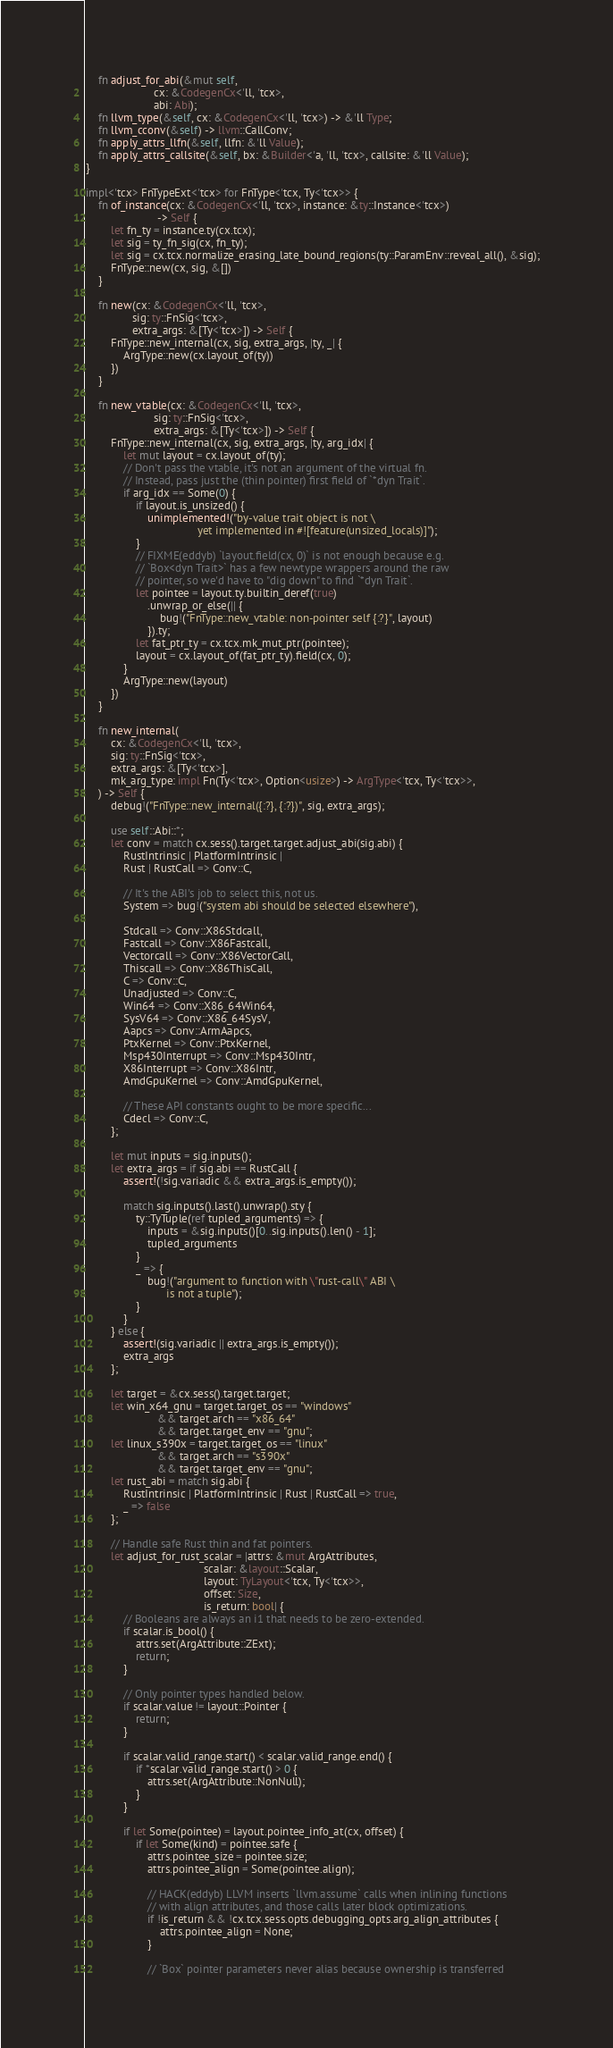<code> <loc_0><loc_0><loc_500><loc_500><_Rust_>    fn adjust_for_abi(&mut self,
                      cx: &CodegenCx<'ll, 'tcx>,
                      abi: Abi);
    fn llvm_type(&self, cx: &CodegenCx<'ll, 'tcx>) -> &'ll Type;
    fn llvm_cconv(&self) -> llvm::CallConv;
    fn apply_attrs_llfn(&self, llfn: &'ll Value);
    fn apply_attrs_callsite(&self, bx: &Builder<'a, 'll, 'tcx>, callsite: &'ll Value);
}

impl<'tcx> FnTypeExt<'tcx> for FnType<'tcx, Ty<'tcx>> {
    fn of_instance(cx: &CodegenCx<'ll, 'tcx>, instance: &ty::Instance<'tcx>)
                       -> Self {
        let fn_ty = instance.ty(cx.tcx);
        let sig = ty_fn_sig(cx, fn_ty);
        let sig = cx.tcx.normalize_erasing_late_bound_regions(ty::ParamEnv::reveal_all(), &sig);
        FnType::new(cx, sig, &[])
    }

    fn new(cx: &CodegenCx<'ll, 'tcx>,
               sig: ty::FnSig<'tcx>,
               extra_args: &[Ty<'tcx>]) -> Self {
        FnType::new_internal(cx, sig, extra_args, |ty, _| {
            ArgType::new(cx.layout_of(ty))
        })
    }

    fn new_vtable(cx: &CodegenCx<'ll, 'tcx>,
                      sig: ty::FnSig<'tcx>,
                      extra_args: &[Ty<'tcx>]) -> Self {
        FnType::new_internal(cx, sig, extra_args, |ty, arg_idx| {
            let mut layout = cx.layout_of(ty);
            // Don't pass the vtable, it's not an argument of the virtual fn.
            // Instead, pass just the (thin pointer) first field of `*dyn Trait`.
            if arg_idx == Some(0) {
                if layout.is_unsized() {
                    unimplemented!("by-value trait object is not \
                                    yet implemented in #![feature(unsized_locals)]");
                }
                // FIXME(eddyb) `layout.field(cx, 0)` is not enough because e.g.
                // `Box<dyn Trait>` has a few newtype wrappers around the raw
                // pointer, so we'd have to "dig down" to find `*dyn Trait`.
                let pointee = layout.ty.builtin_deref(true)
                    .unwrap_or_else(|| {
                        bug!("FnType::new_vtable: non-pointer self {:?}", layout)
                    }).ty;
                let fat_ptr_ty = cx.tcx.mk_mut_ptr(pointee);
                layout = cx.layout_of(fat_ptr_ty).field(cx, 0);
            }
            ArgType::new(layout)
        })
    }

    fn new_internal(
        cx: &CodegenCx<'ll, 'tcx>,
        sig: ty::FnSig<'tcx>,
        extra_args: &[Ty<'tcx>],
        mk_arg_type: impl Fn(Ty<'tcx>, Option<usize>) -> ArgType<'tcx, Ty<'tcx>>,
    ) -> Self {
        debug!("FnType::new_internal({:?}, {:?})", sig, extra_args);

        use self::Abi::*;
        let conv = match cx.sess().target.target.adjust_abi(sig.abi) {
            RustIntrinsic | PlatformIntrinsic |
            Rust | RustCall => Conv::C,

            // It's the ABI's job to select this, not us.
            System => bug!("system abi should be selected elsewhere"),

            Stdcall => Conv::X86Stdcall,
            Fastcall => Conv::X86Fastcall,
            Vectorcall => Conv::X86VectorCall,
            Thiscall => Conv::X86ThisCall,
            C => Conv::C,
            Unadjusted => Conv::C,
            Win64 => Conv::X86_64Win64,
            SysV64 => Conv::X86_64SysV,
            Aapcs => Conv::ArmAapcs,
            PtxKernel => Conv::PtxKernel,
            Msp430Interrupt => Conv::Msp430Intr,
            X86Interrupt => Conv::X86Intr,
            AmdGpuKernel => Conv::AmdGpuKernel,

            // These API constants ought to be more specific...
            Cdecl => Conv::C,
        };

        let mut inputs = sig.inputs();
        let extra_args = if sig.abi == RustCall {
            assert!(!sig.variadic && extra_args.is_empty());

            match sig.inputs().last().unwrap().sty {
                ty::TyTuple(ref tupled_arguments) => {
                    inputs = &sig.inputs()[0..sig.inputs().len() - 1];
                    tupled_arguments
                }
                _ => {
                    bug!("argument to function with \"rust-call\" ABI \
                          is not a tuple");
                }
            }
        } else {
            assert!(sig.variadic || extra_args.is_empty());
            extra_args
        };

        let target = &cx.sess().target.target;
        let win_x64_gnu = target.target_os == "windows"
                       && target.arch == "x86_64"
                       && target.target_env == "gnu";
        let linux_s390x = target.target_os == "linux"
                       && target.arch == "s390x"
                       && target.target_env == "gnu";
        let rust_abi = match sig.abi {
            RustIntrinsic | PlatformIntrinsic | Rust | RustCall => true,
            _ => false
        };

        // Handle safe Rust thin and fat pointers.
        let adjust_for_rust_scalar = |attrs: &mut ArgAttributes,
                                      scalar: &layout::Scalar,
                                      layout: TyLayout<'tcx, Ty<'tcx>>,
                                      offset: Size,
                                      is_return: bool| {
            // Booleans are always an i1 that needs to be zero-extended.
            if scalar.is_bool() {
                attrs.set(ArgAttribute::ZExt);
                return;
            }

            // Only pointer types handled below.
            if scalar.value != layout::Pointer {
                return;
            }

            if scalar.valid_range.start() < scalar.valid_range.end() {
                if *scalar.valid_range.start() > 0 {
                    attrs.set(ArgAttribute::NonNull);
                }
            }

            if let Some(pointee) = layout.pointee_info_at(cx, offset) {
                if let Some(kind) = pointee.safe {
                    attrs.pointee_size = pointee.size;
                    attrs.pointee_align = Some(pointee.align);

                    // HACK(eddyb) LLVM inserts `llvm.assume` calls when inlining functions
                    // with align attributes, and those calls later block optimizations.
                    if !is_return && !cx.tcx.sess.opts.debugging_opts.arg_align_attributes {
                        attrs.pointee_align = None;
                    }

                    // `Box` pointer parameters never alias because ownership is transferred</code> 